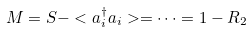<formula> <loc_0><loc_0><loc_500><loc_500>M = S - < a ^ { \dagger } _ { i } a _ { i } > = \cdots = 1 - R _ { 2 }</formula> 